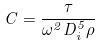Convert formula to latex. <formula><loc_0><loc_0><loc_500><loc_500>C = \frac { \tau } { \omega ^ { 2 } D _ { i } ^ { 5 } \rho }</formula> 